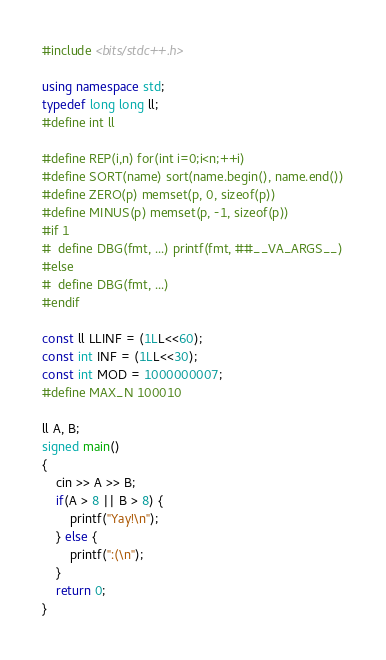Convert code to text. <code><loc_0><loc_0><loc_500><loc_500><_C++_>#include <bits/stdc++.h>

using namespace std;
typedef long long ll;
#define int ll

#define REP(i,n) for(int i=0;i<n;++i)
#define SORT(name) sort(name.begin(), name.end())
#define ZERO(p) memset(p, 0, sizeof(p))
#define MINUS(p) memset(p, -1, sizeof(p))
#if 1
#  define DBG(fmt, ...) printf(fmt, ##__VA_ARGS__)
#else
#  define DBG(fmt, ...)
#endif

const ll LLINF = (1LL<<60);
const int INF = (1LL<<30);
const int MOD = 1000000007;
#define MAX_N 100010

ll A, B;
signed main()
{
    cin >> A >> B;
    if(A > 8 || B > 8) {
        printf("Yay!\n");
    } else {
        printf(":(\n");
    }
    return 0;
}
</code> 